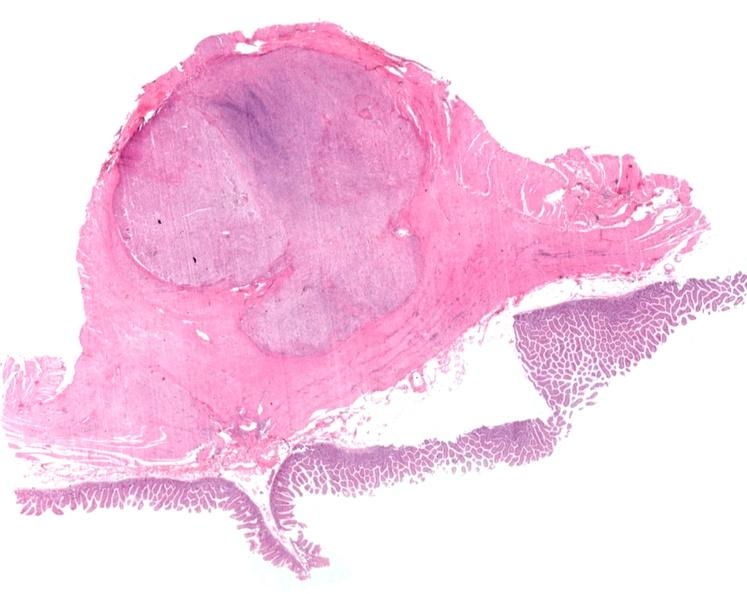what does this image show?
Answer the question using a single word or phrase. Stomach 